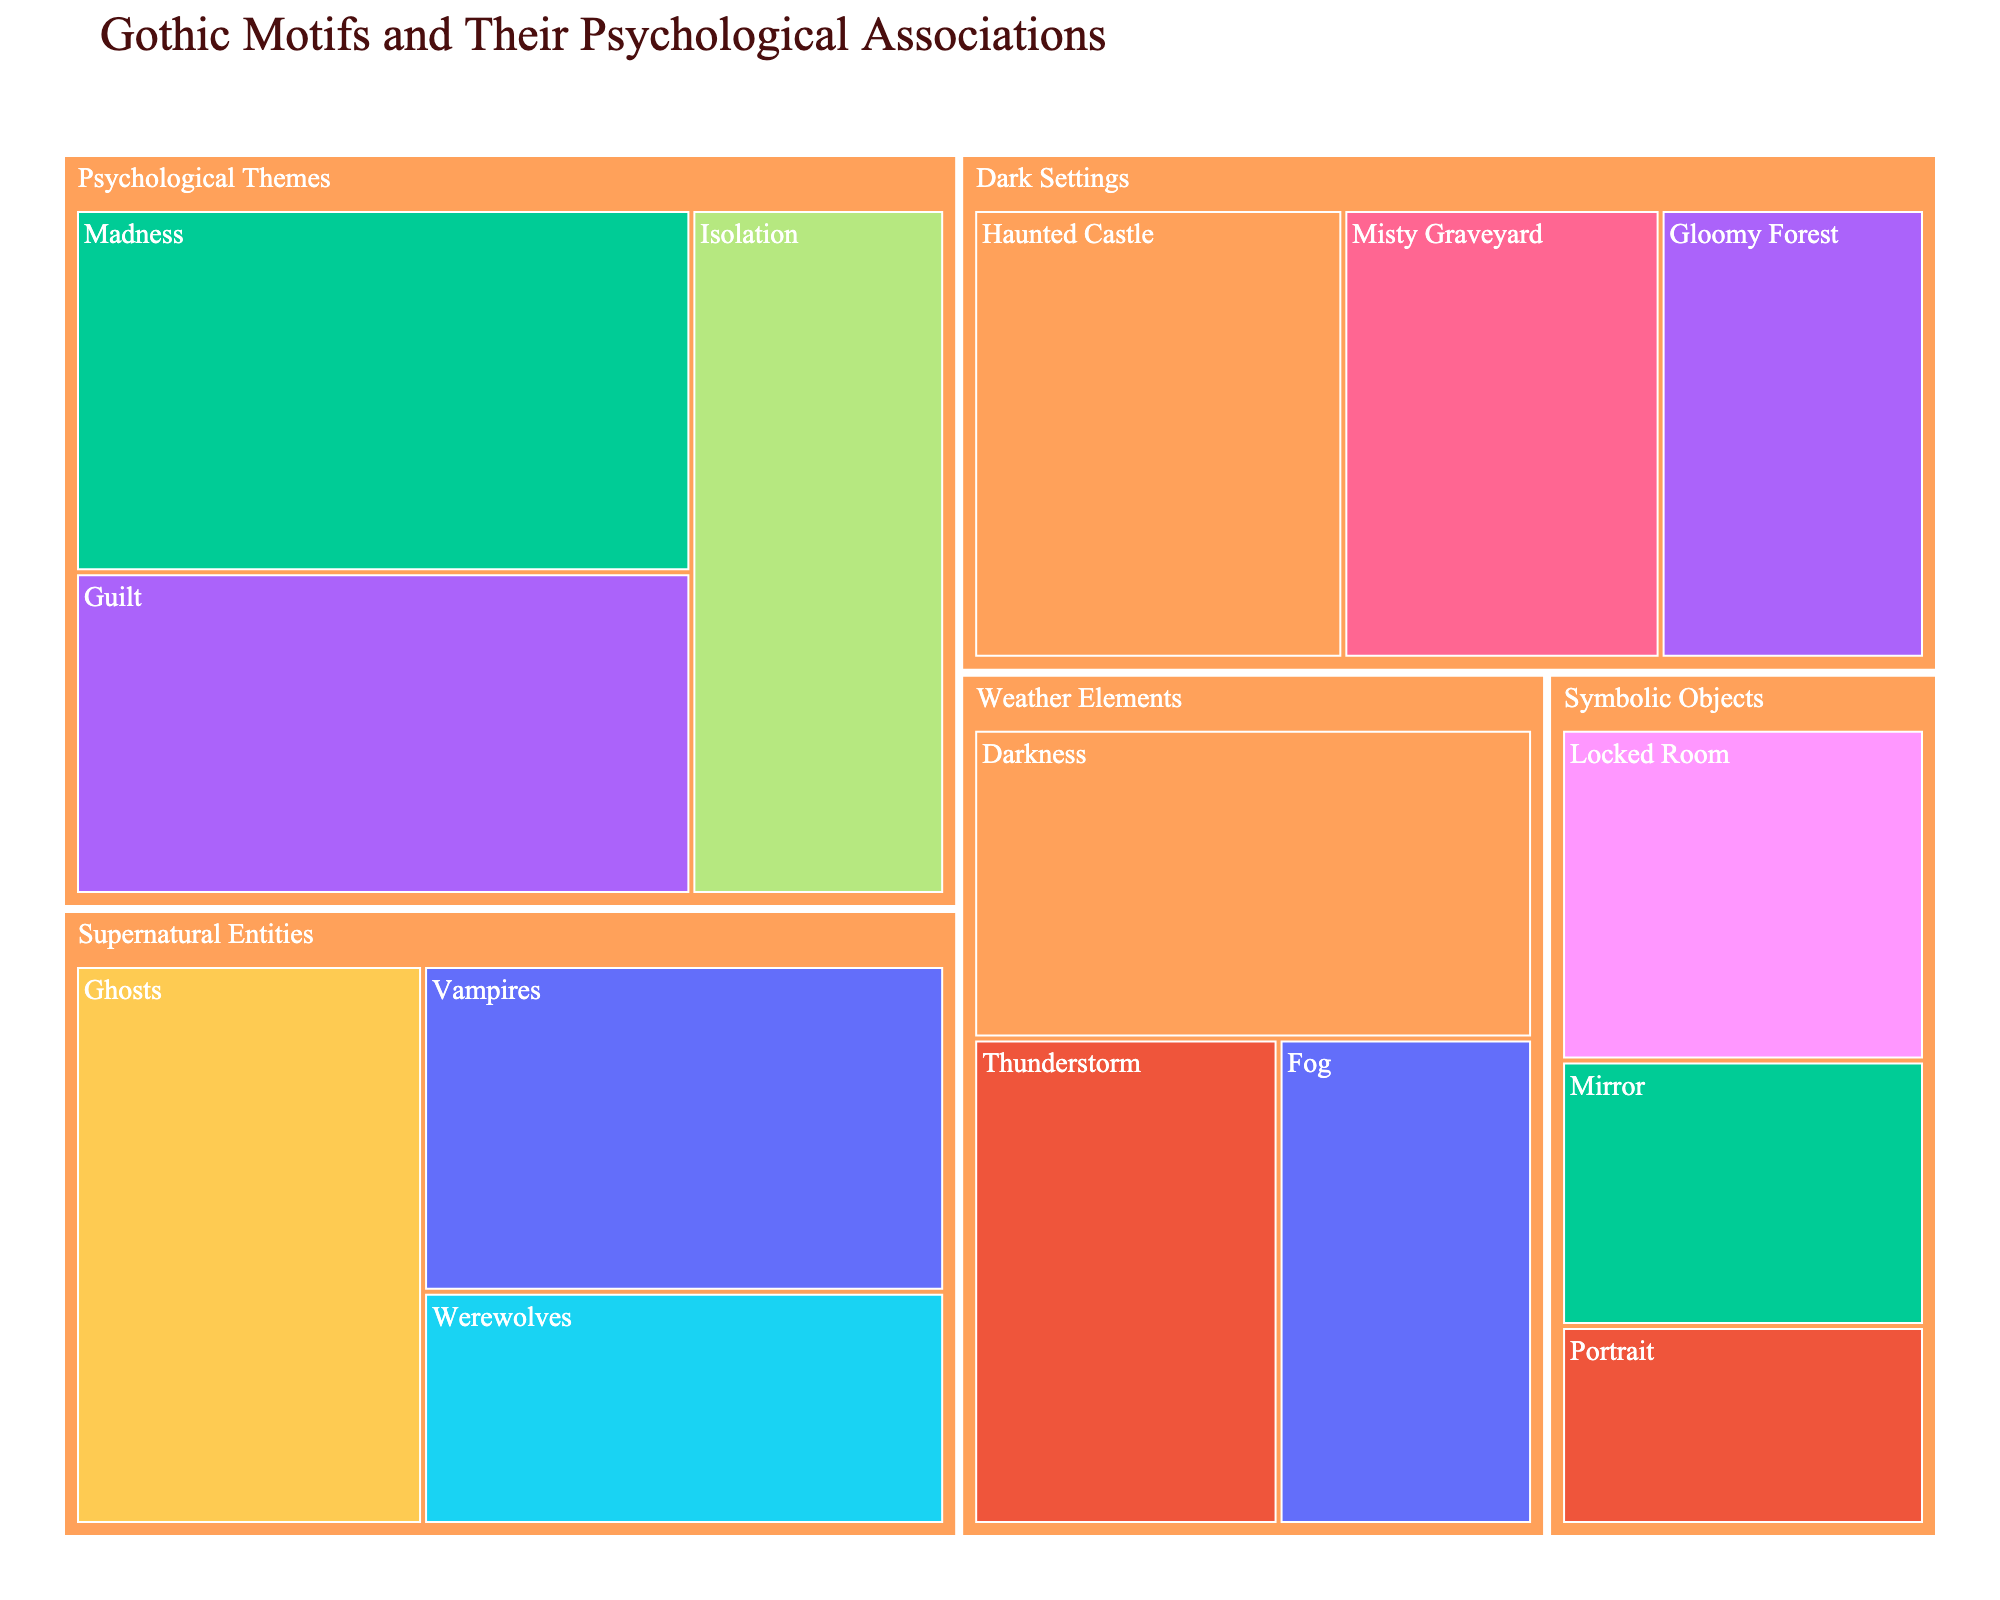What is the title of the treemap? The title is typically located at the top of the visualization. By looking at the top part of the figure, you can find the text indicating what the chart is depicting.
Answer: Gothic Motifs and Their Psychological Associations Which motif has the highest prevalence within the "Supernatural Entities" archetype? In the "Supernatural Entities" group, look at the size of each motif block and compare their prevalence values indicated within each block.
Answer: Ghosts What psychological association is linked to the motif "Mirror"? Find the "Symbolic Objects" archetype group, then locate the "Mirror" motif within it and identify the associated psychological concept.
Answer: Self-Reflection How many motifs are there under the "Weather Elements" archetype? Count the number of distinct motif blocks colored and labeled within the "Weather Elements" group.
Answer: 3 Which archetype has the motif associated with "Primal Fears"? Search for the motif labeled with "Primal Fears" in the figure and identify its corresponding archetype group that it's part of.
Answer: Dark Settings What is the sum of the prevalence rates for all motifs in the "Psychological Themes" archetype? Locate each motif within the "Psychological Themes" group and sum their prevalence rates indicated within their respective blocks: Madness (45) + Guilt (40) + Isolation (35).
Answer: 120 Compare the motifs "Guilt" and "Vampires". Which has higher prevalence and by how much? Identify both "Guilt" and "Vampires" motifs, compare their prevalence values, and calculate the difference: Guilt (40) vs. Vampires (35). 40 is greater than 35, and 40 - 35 = 5.
Answer: Guilt by 5 Are there any motifs that share the same psychological association? If yes, give an example. Look through the list of psychological associations in the different motifs and find if any occur more than once. For example, "Fear of the Unknown" appears in both "Dark Settings" and "Weather Elements".
Answer: Yes, Fear of the Unknown Which motif related to "Psychological Themes" has the strongest link with "Loss of Control"? Find the "Psychological Themes" archetype and identify the motif that is associated with "Loss of Control".
Answer: Madness 